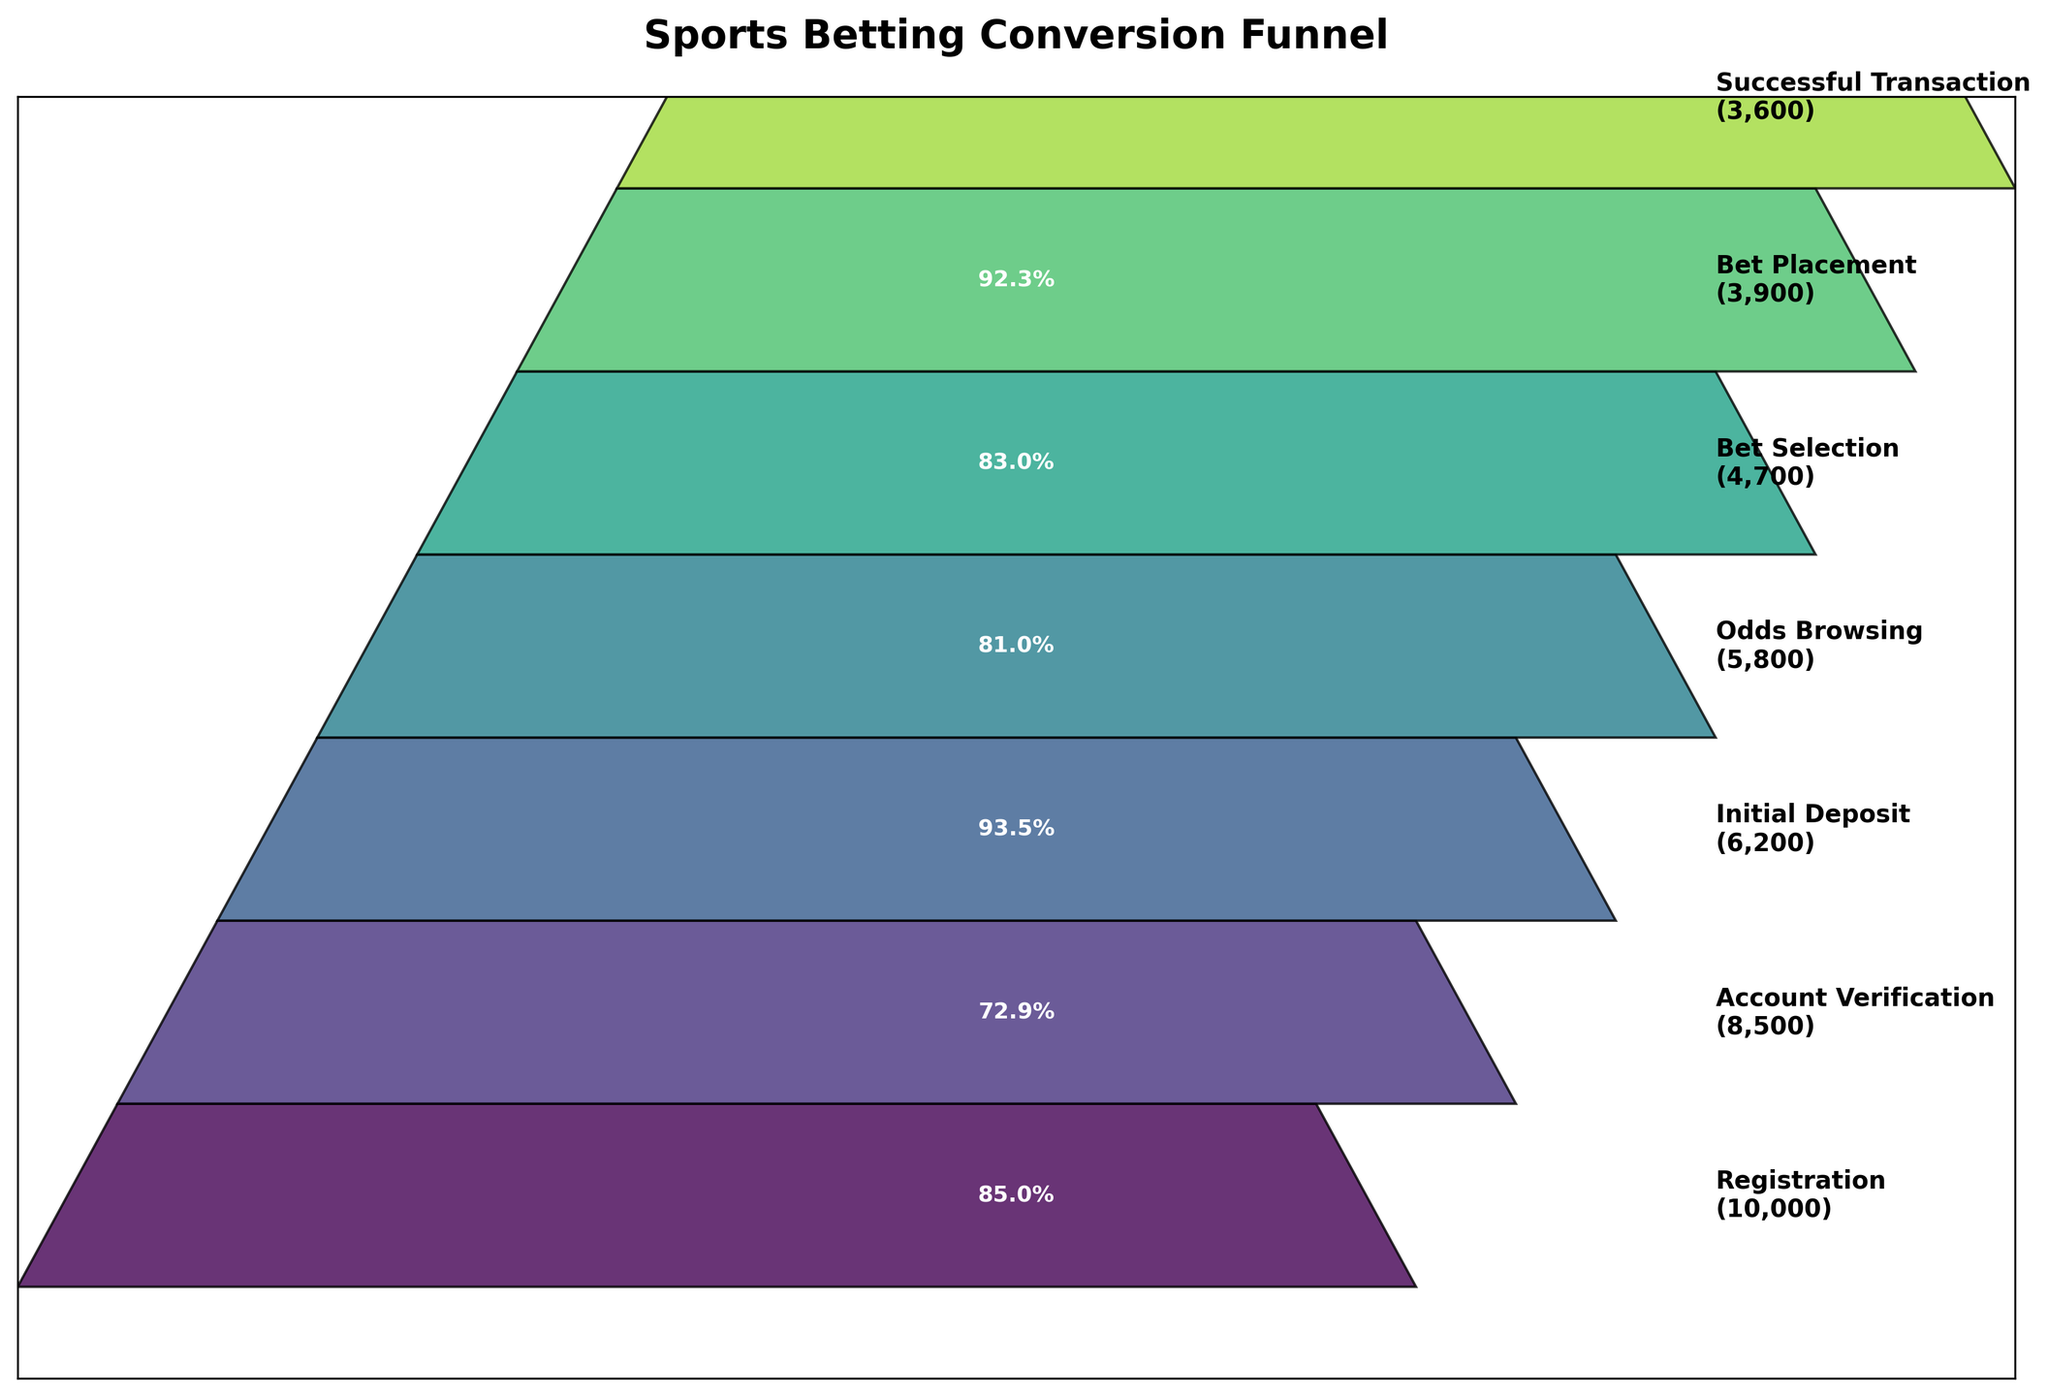What is the title of the funnel chart? The title is usually placed at the top of the chart and provides a summary of what the chart represents. In this case, it reads "Sports Betting Conversion Funnel."
Answer: Sports Betting Conversion Funnel How many stages are represented in the funnel chart? By counting the labeled segments in the funnel, we see that there are 7 stages from top to bottom.
Answer: 7 What percentage of users who registered completed the account verification stage? To find the percentage, divide the number of users who completed the account verification stage (8500) by the number of users who registered (10000) and multiply by 100. \(\frac{8500}{10000} \times 100 = 85\%\)
Answer: 85% Which stage has the highest dropout rate? To determine the highest dropout rate, calculate the percentage decrease between each consecutive stage. The largest drop occurs between the account verification (8500) and initial deposit (6200). \(\frac{8500 - 6200}{8500} \times 100 ≈ 34.3\%\)
Answer: Initial Deposit What proportion of users who browsed odds ended up placing a bet? Users who browsed odds: 5800, Users who placed a bet: 3900. Calculate the proportion: \(\frac{3900}{5800} \approx 67.2\%\)
Answer: 67.2% What is the difference in user count between the Bet Selection and Successful Transaction stages? Subtract the number of users in the Successful Transaction stage (3600) from those in the Bet Selection stage (4700). \(4700 - 3600 = 1100\)
Answer: 1100 What fraction of users who placed a bet had a successful transaction? Number of bet placements: 3900, Number of successful transactions: 3600. Calculate the fraction: \(\frac{3600}{3900} \approx 92.3\%\)
Answer: 92.3% Which stages show more than 90% retention from the previous stage? Checking the percentage decreases between stages, the only transitions above 90% retention are: Registration to Account Verification (85%), Initial Deposit to Odds Browsing (93.5%), Bet Selection to Bet Placement (83%), and Bet Placement to Successful Transaction (92.3%).
Answer: Odds Browsing, Bet Placement to Successful Transaction What stage follows the Initial Deposit stage? Following the sequence from top to bottom, the stage that comes after the Initial Deposit is Odds Browsing.
Answer: Odds Browsing 